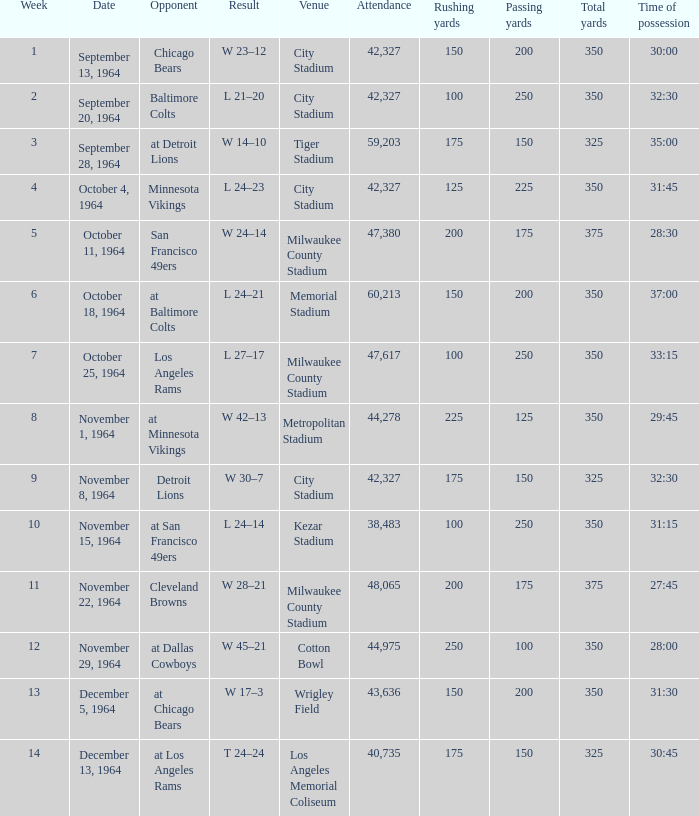What is the average week of the game on November 22, 1964 attended by 48,065? None. 